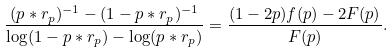Convert formula to latex. <formula><loc_0><loc_0><loc_500><loc_500>\frac { ( p * r _ { p } ) ^ { - 1 } - ( 1 - p * r _ { p } ) ^ { - 1 } } { \log ( 1 - p * r _ { p } ) - \log ( p * r _ { p } ) } = \frac { ( 1 - 2 p ) f ( p ) - 2 F ( p ) } { F ( p ) } .</formula> 